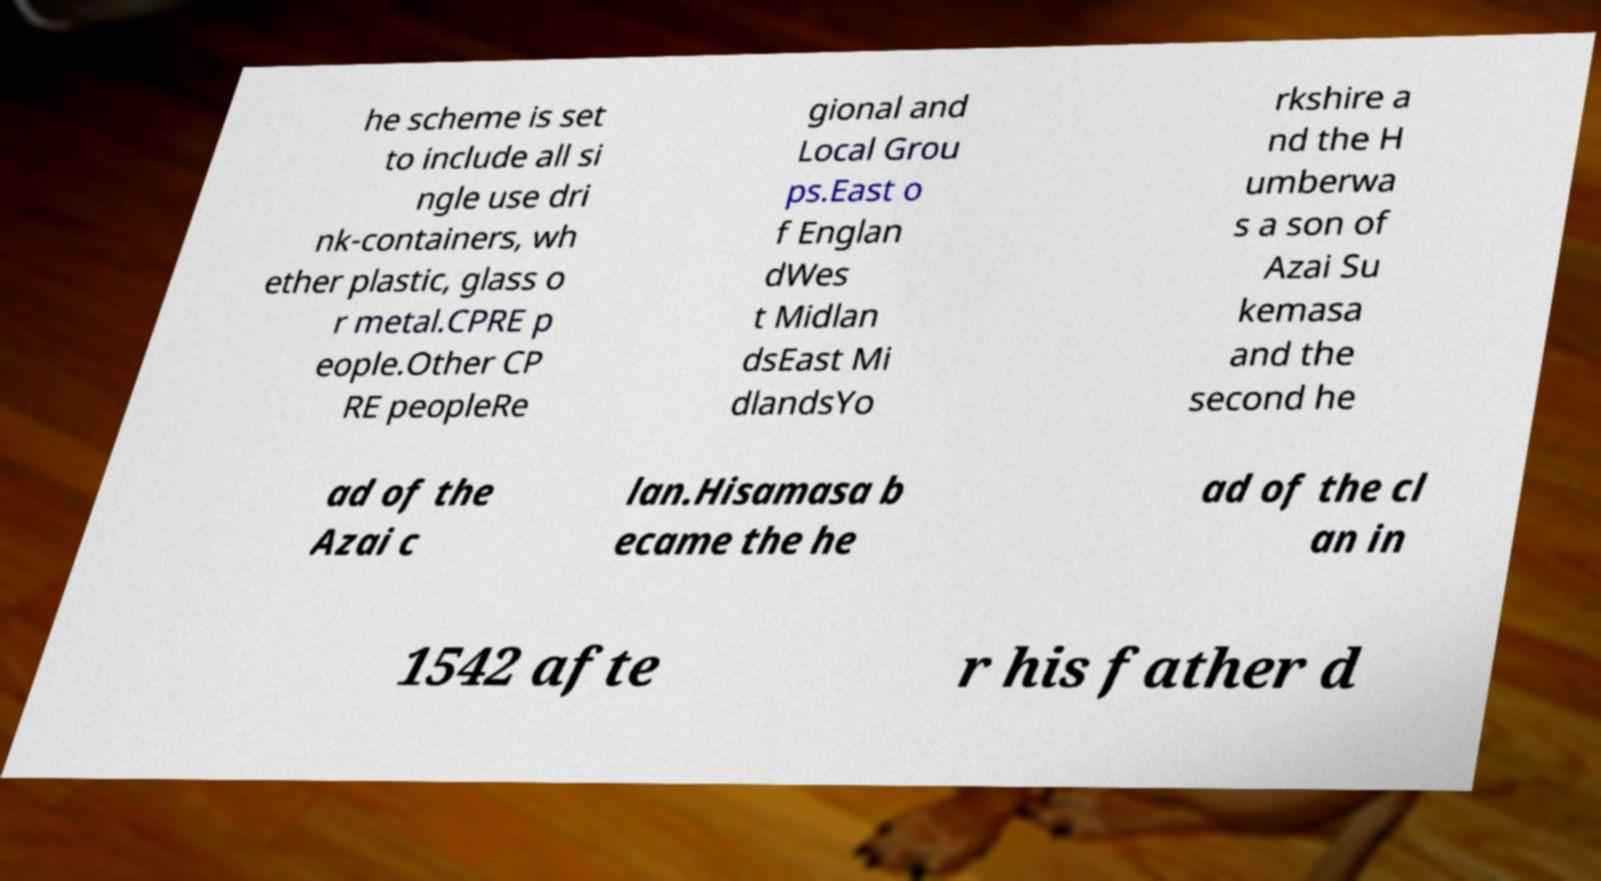Please identify and transcribe the text found in this image. he scheme is set to include all si ngle use dri nk-containers, wh ether plastic, glass o r metal.CPRE p eople.Other CP RE peopleRe gional and Local Grou ps.East o f Englan dWes t Midlan dsEast Mi dlandsYo rkshire a nd the H umberwa s a son of Azai Su kemasa and the second he ad of the Azai c lan.Hisamasa b ecame the he ad of the cl an in 1542 afte r his father d 